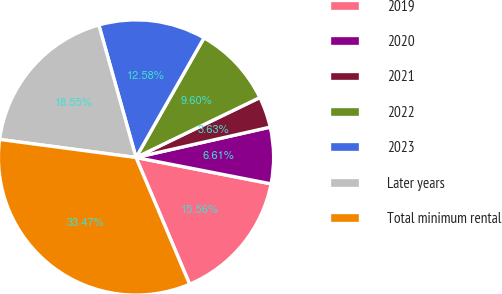Convert chart to OTSL. <chart><loc_0><loc_0><loc_500><loc_500><pie_chart><fcel>2019<fcel>2020<fcel>2021<fcel>2022<fcel>2023<fcel>Later years<fcel>Total minimum rental<nl><fcel>15.56%<fcel>6.61%<fcel>3.63%<fcel>9.6%<fcel>12.58%<fcel>18.55%<fcel>33.47%<nl></chart> 